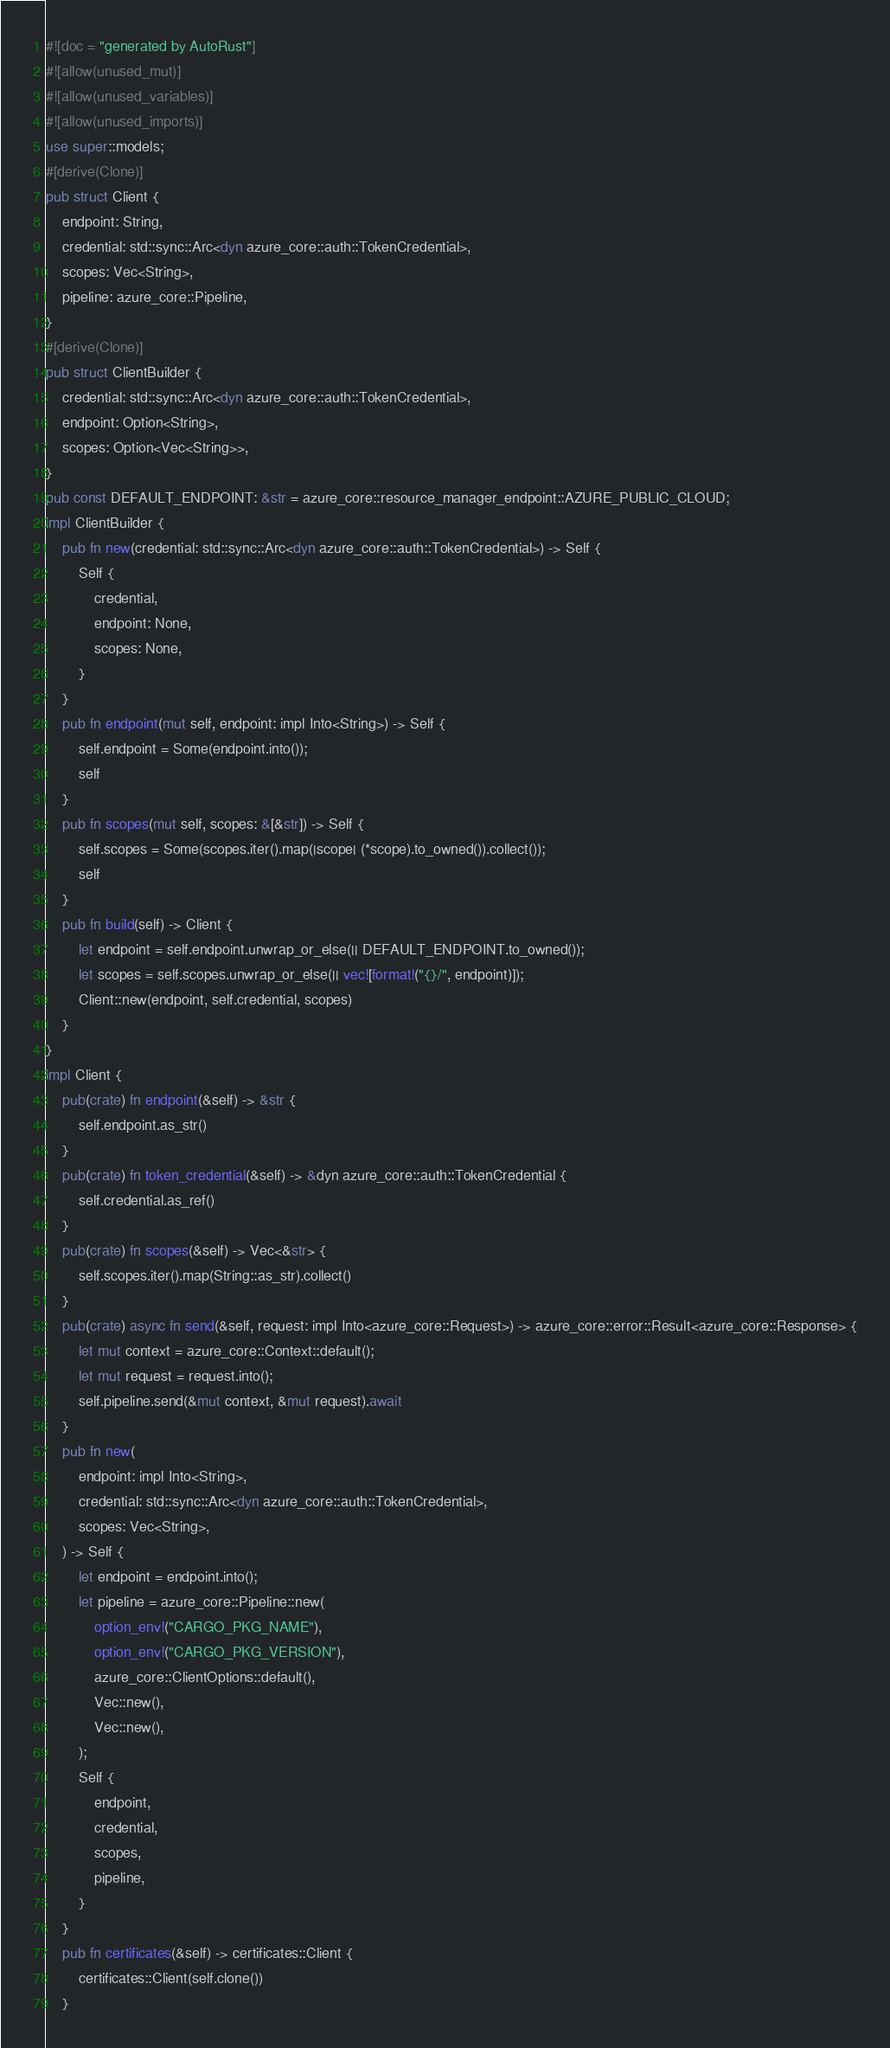Convert code to text. <code><loc_0><loc_0><loc_500><loc_500><_Rust_>#![doc = "generated by AutoRust"]
#![allow(unused_mut)]
#![allow(unused_variables)]
#![allow(unused_imports)]
use super::models;
#[derive(Clone)]
pub struct Client {
    endpoint: String,
    credential: std::sync::Arc<dyn azure_core::auth::TokenCredential>,
    scopes: Vec<String>,
    pipeline: azure_core::Pipeline,
}
#[derive(Clone)]
pub struct ClientBuilder {
    credential: std::sync::Arc<dyn azure_core::auth::TokenCredential>,
    endpoint: Option<String>,
    scopes: Option<Vec<String>>,
}
pub const DEFAULT_ENDPOINT: &str = azure_core::resource_manager_endpoint::AZURE_PUBLIC_CLOUD;
impl ClientBuilder {
    pub fn new(credential: std::sync::Arc<dyn azure_core::auth::TokenCredential>) -> Self {
        Self {
            credential,
            endpoint: None,
            scopes: None,
        }
    }
    pub fn endpoint(mut self, endpoint: impl Into<String>) -> Self {
        self.endpoint = Some(endpoint.into());
        self
    }
    pub fn scopes(mut self, scopes: &[&str]) -> Self {
        self.scopes = Some(scopes.iter().map(|scope| (*scope).to_owned()).collect());
        self
    }
    pub fn build(self) -> Client {
        let endpoint = self.endpoint.unwrap_or_else(|| DEFAULT_ENDPOINT.to_owned());
        let scopes = self.scopes.unwrap_or_else(|| vec![format!("{}/", endpoint)]);
        Client::new(endpoint, self.credential, scopes)
    }
}
impl Client {
    pub(crate) fn endpoint(&self) -> &str {
        self.endpoint.as_str()
    }
    pub(crate) fn token_credential(&self) -> &dyn azure_core::auth::TokenCredential {
        self.credential.as_ref()
    }
    pub(crate) fn scopes(&self) -> Vec<&str> {
        self.scopes.iter().map(String::as_str).collect()
    }
    pub(crate) async fn send(&self, request: impl Into<azure_core::Request>) -> azure_core::error::Result<azure_core::Response> {
        let mut context = azure_core::Context::default();
        let mut request = request.into();
        self.pipeline.send(&mut context, &mut request).await
    }
    pub fn new(
        endpoint: impl Into<String>,
        credential: std::sync::Arc<dyn azure_core::auth::TokenCredential>,
        scopes: Vec<String>,
    ) -> Self {
        let endpoint = endpoint.into();
        let pipeline = azure_core::Pipeline::new(
            option_env!("CARGO_PKG_NAME"),
            option_env!("CARGO_PKG_VERSION"),
            azure_core::ClientOptions::default(),
            Vec::new(),
            Vec::new(),
        );
        Self {
            endpoint,
            credential,
            scopes,
            pipeline,
        }
    }
    pub fn certificates(&self) -> certificates::Client {
        certificates::Client(self.clone())
    }</code> 